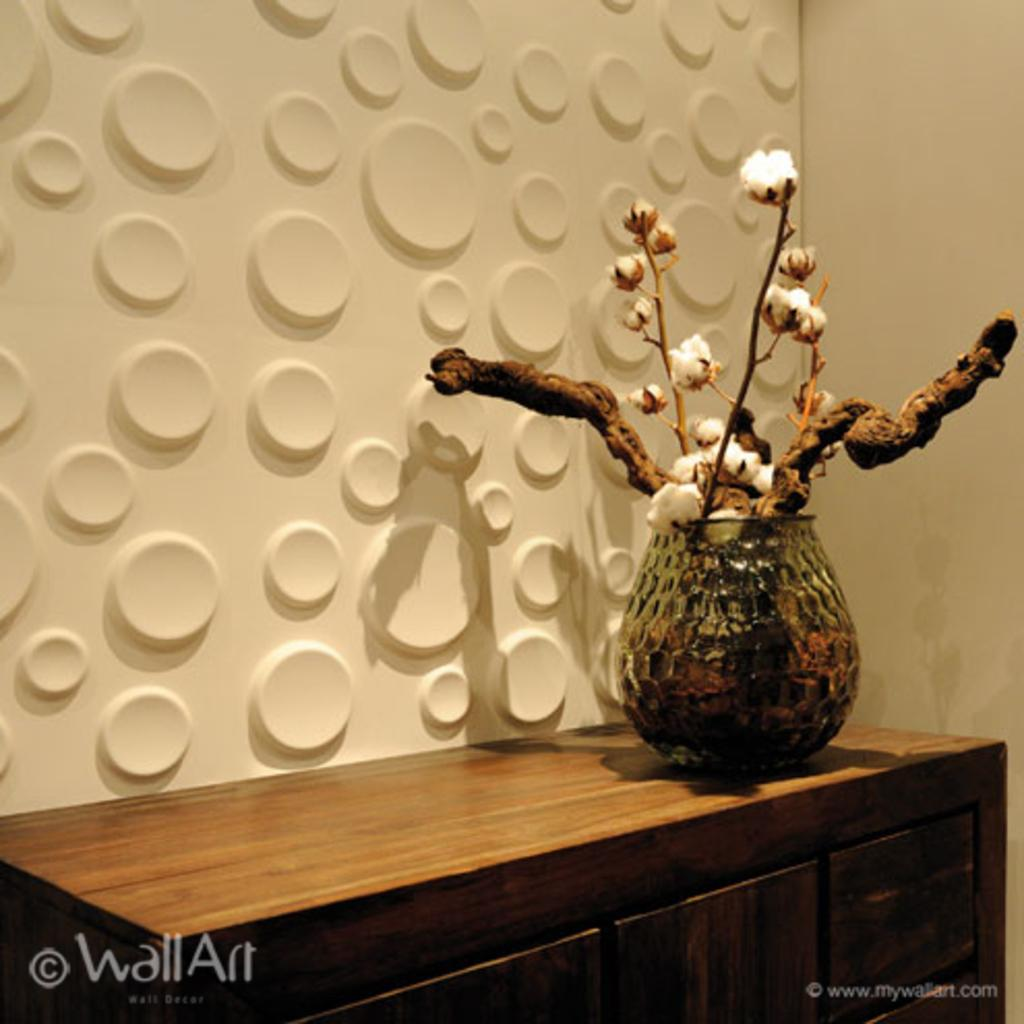What is the main object in the image? There is a flower vase in the image. What type of flowers are in the vase? The flower vase contains cotton flowers. What type of furniture is present in the image? There is a wooden table in the image. Where is the wooden table located in the image? The wooden table is placed at the bottom of the image. How does the servant assist the person in the image? There is no servant present in the image. What type of sail is visible in the image? There is no sail present in the image. 